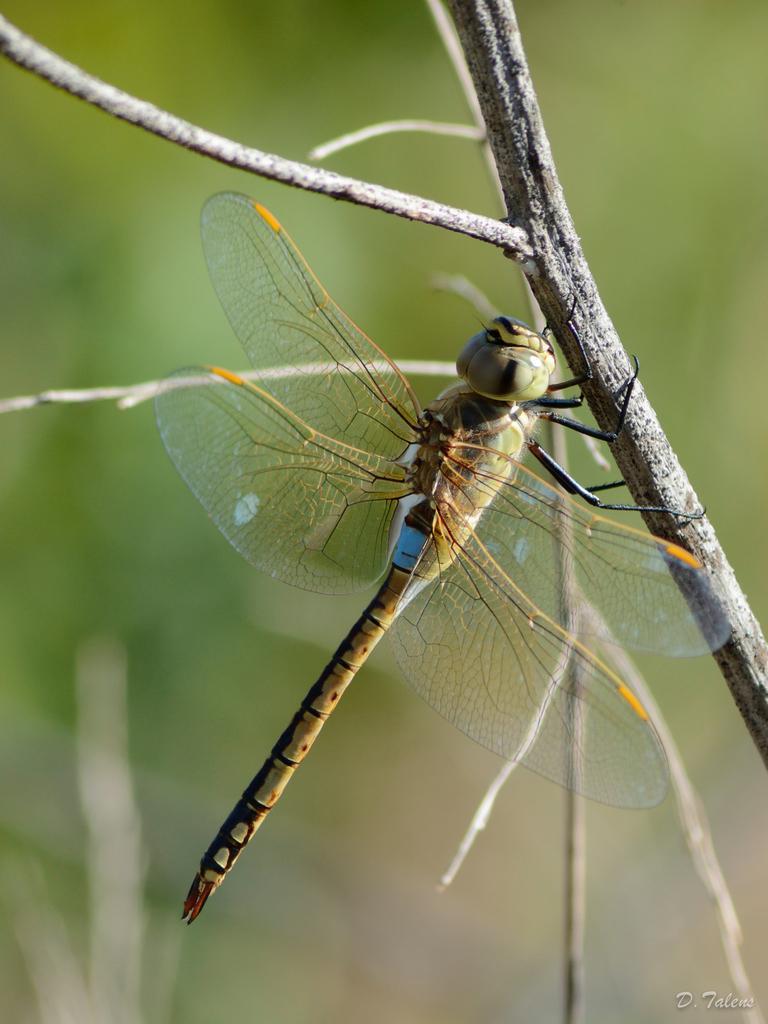In one or two sentences, can you explain what this image depicts? Background portion of the picture is blurred. In this picture we can see the twigs and we can see a dragonfly holding a twig. 